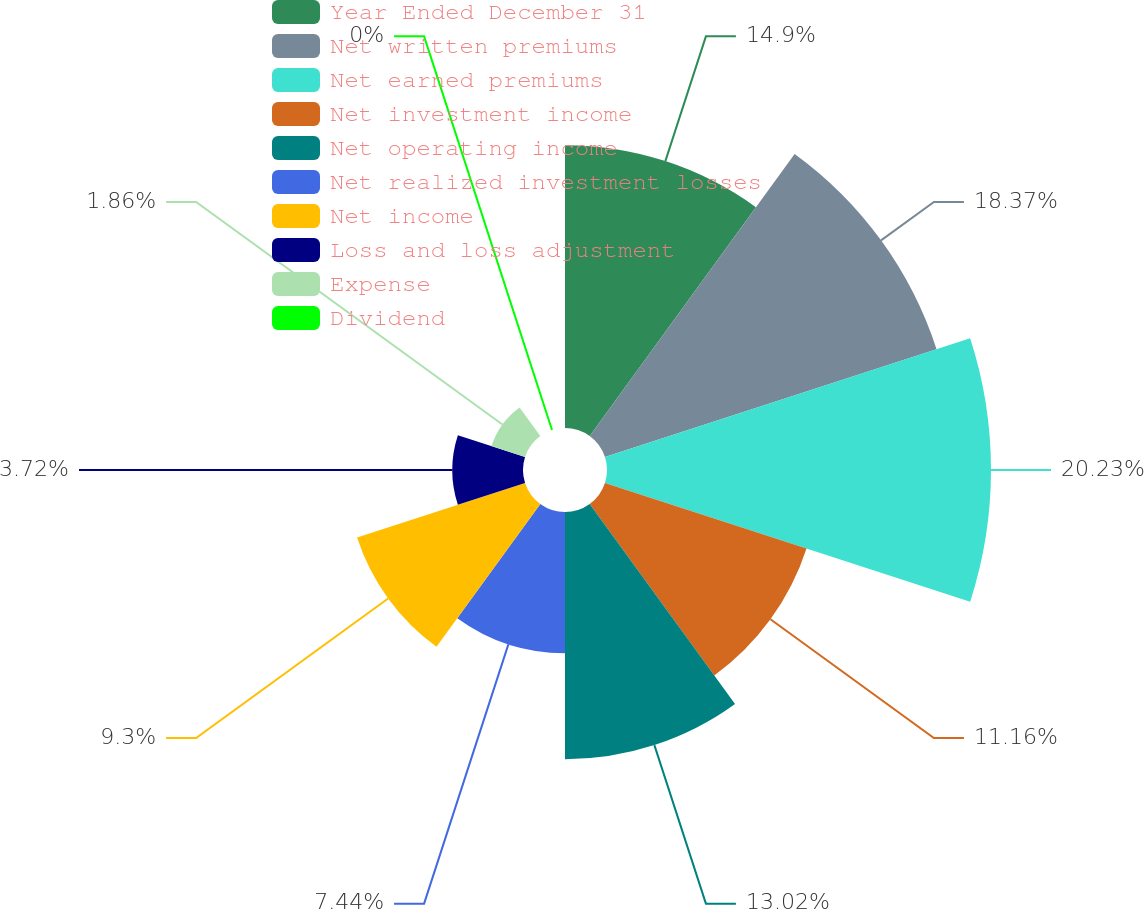<chart> <loc_0><loc_0><loc_500><loc_500><pie_chart><fcel>Year Ended December 31<fcel>Net written premiums<fcel>Net earned premiums<fcel>Net investment income<fcel>Net operating income<fcel>Net realized investment losses<fcel>Net income<fcel>Loss and loss adjustment<fcel>Expense<fcel>Dividend<nl><fcel>14.89%<fcel>18.36%<fcel>20.22%<fcel>11.16%<fcel>13.02%<fcel>7.44%<fcel>9.3%<fcel>3.72%<fcel>1.86%<fcel>0.0%<nl></chart> 